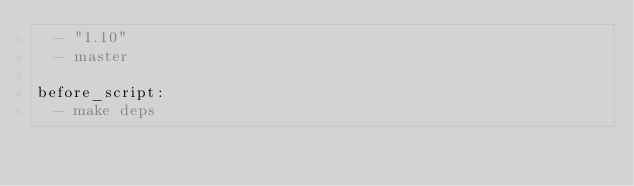<code> <loc_0><loc_0><loc_500><loc_500><_YAML_>  - "1.10"
  - master

before_script:
  - make deps
</code> 